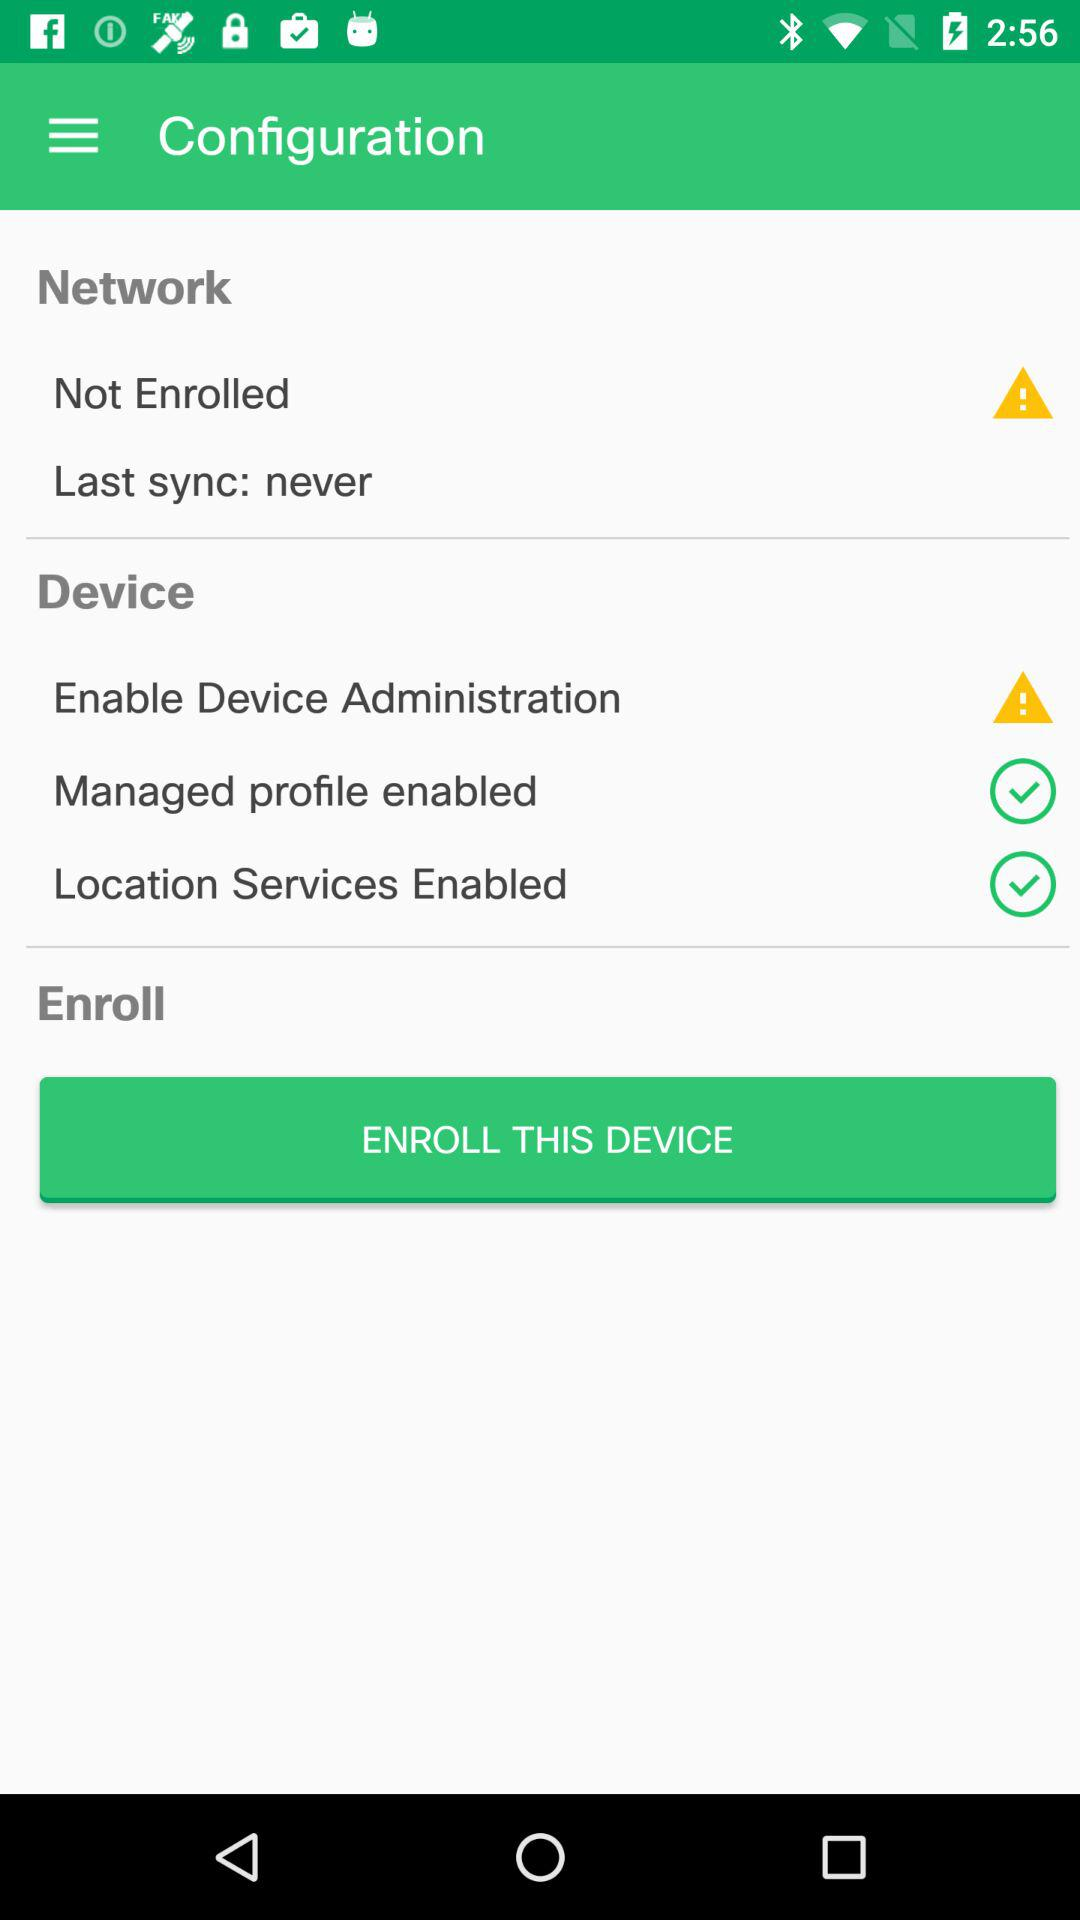What is the status of "Managed profile"? The status is "on". 